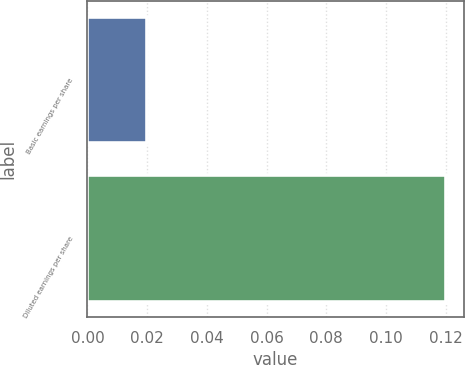<chart> <loc_0><loc_0><loc_500><loc_500><bar_chart><fcel>Basic earnings per share<fcel>Diluted earnings per share<nl><fcel>0.02<fcel>0.12<nl></chart> 